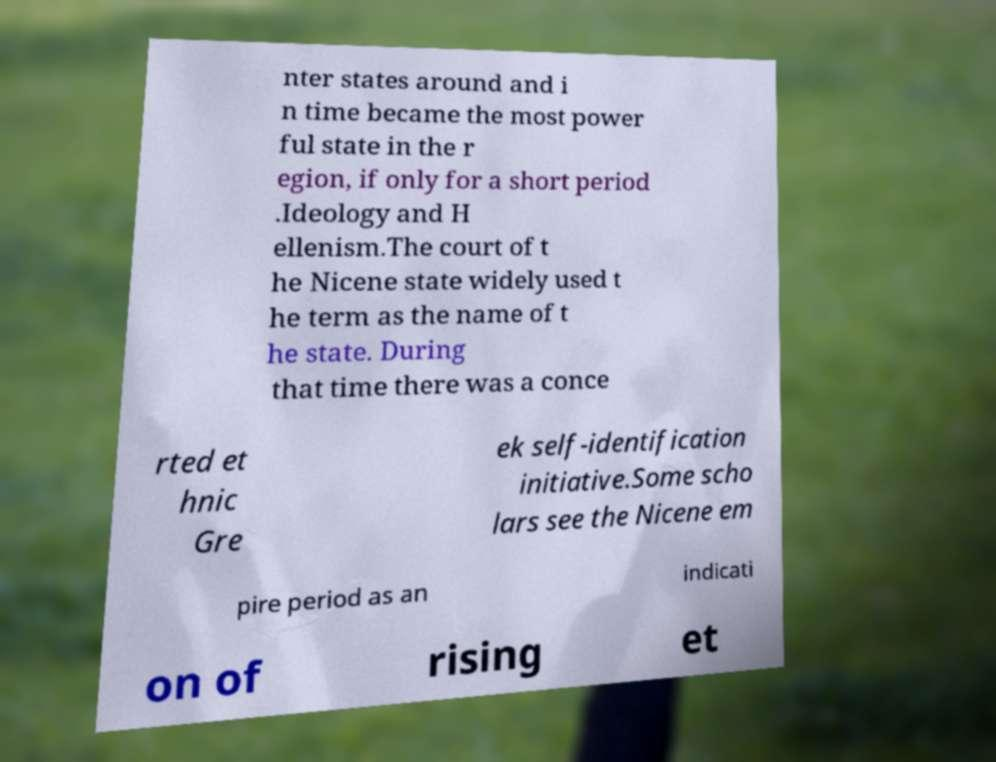I need the written content from this picture converted into text. Can you do that? nter states around and i n time became the most power ful state in the r egion, if only for a short period .Ideology and H ellenism.The court of t he Nicene state widely used t he term as the name of t he state. During that time there was a conce rted et hnic Gre ek self-identification initiative.Some scho lars see the Nicene em pire period as an indicati on of rising et 